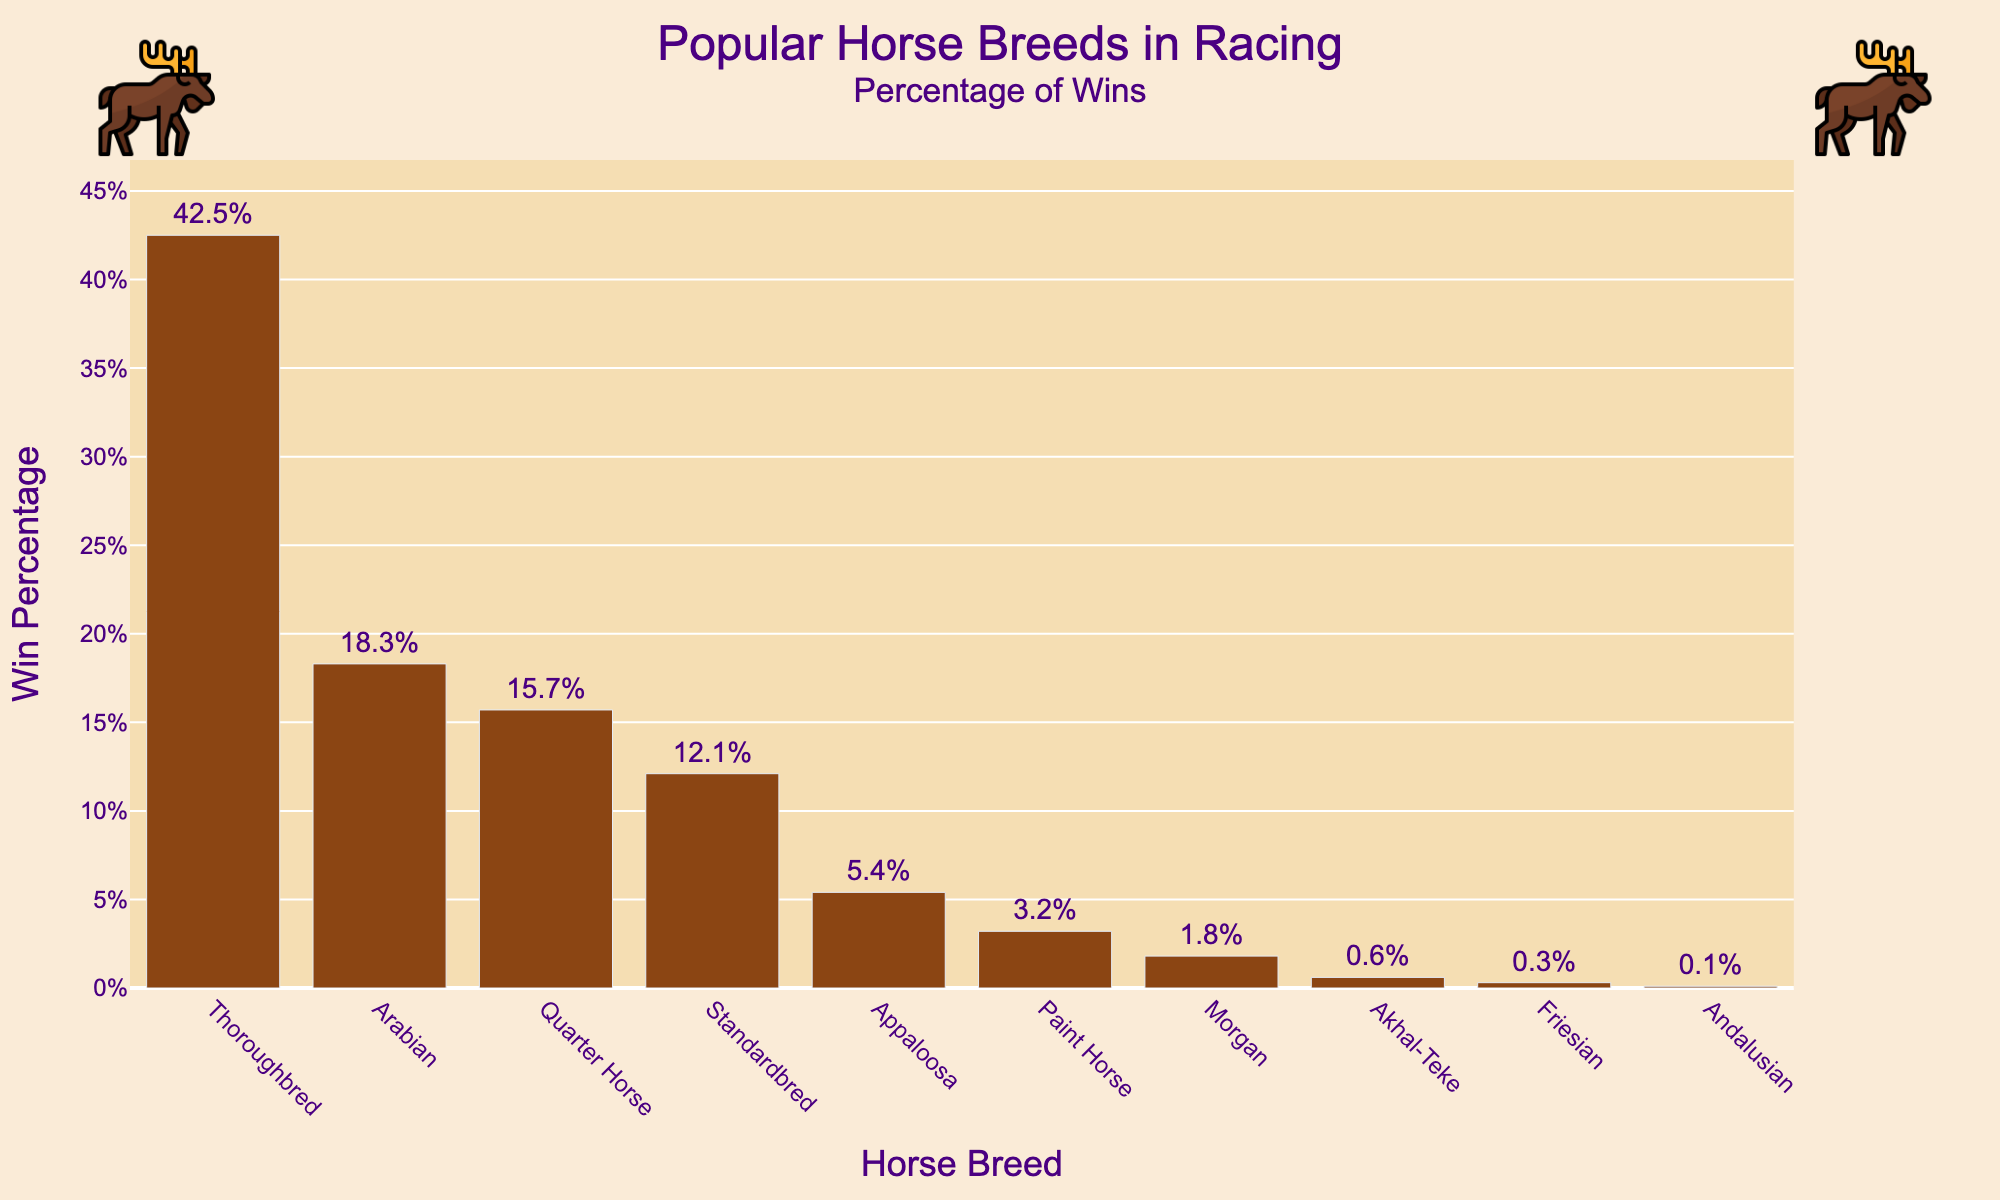Which horse breed has the highest win percentage? From the bar chart, the Thoroughbred breed has the tallest bar. Its win percentage text shows 42.5%, which is higher than the other breeds.
Answer: Thoroughbred Which two breeds have the closest win percentages? By examining the lengths of the bars and their corresponding percentages, the Quarter Horse (15.7%) and Standardbred (12.1%) have the closest win percentages, differing by only 3.6%.
Answer: Quarter Horse and Standardbred How much higher is the win percentage of Thoroughbreds compared to Arabians? The win percentage of Thoroughbreds is 42.5%, and for Arabians, it is 18.3%. The difference is calculated as 42.5% - 18.3% = 24.2%.
Answer: 24.2% What is the combined win percentage of the top three breeds? The top three breeds by win percentage are Thoroughbred (42.5%), Arabian (18.3%), and Quarter Horse (15.7%). The combined win percentage is 42.5 + 18.3 + 15.7 = 76.5%.
Answer: 76.5% Which breed has a win percentage below 1%? By observing the bar heights and corresponding win percentages, Friesian (0.3%) and Andalusian (0.1%) both fall below 1%.
Answer: Friesian, Andalusian Is the sum of the win percentages of Paint Horse, Morgan, and Akhal-Teke greater than the win percentage of Arabian? The win percentages are: Paint Horse (3.2%), Morgan (1.8%), and Akhal-Teke (0.6%). The sum is 3.2 + 1.8 + 0.6 = 5.6%, which is less than Arabian's 18.3%.
Answer: No Which breed has a win percentage closest to 5%? Appaloosa has a win percentage of 5.4%, which is the closest to 5%.
Answer: Appaloosa By how much does the win percentage of the lowest-ranked breed (Andalusian) differ from the highest-ranked breed (Thoroughbred)? The win percentage of Thoroughbred is 42.5%, and Andalusian is 0.1%. The difference is 42.5% - 0.1% = 42.4%.
Answer: 42.4% What is the difference in win percentage between Quarter Horse and Paint Horse? Quarter Horse has a win percentage of 15.7% and Paint Horse 3.2%. The difference is 15.7% - 3.2% = 12.5%.
Answer: 12.5% Is the win percentage of Standardbred more than double that of Paint Horse? Standardbred has a win percentage of 12.1%, and Paint Horse 3.2%. Double the win percentage of Paint Horse is 3.2% * 2 = 6.4%, which is less than Standardbred's 12.1%.
Answer: Yes 